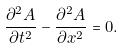Convert formula to latex. <formula><loc_0><loc_0><loc_500><loc_500>\frac { { { \partial ^ { 2 } } A } } { \partial t ^ { 2 } } - \frac { { { \partial ^ { 2 } } A } } { \partial x ^ { 2 } } = 0 .</formula> 